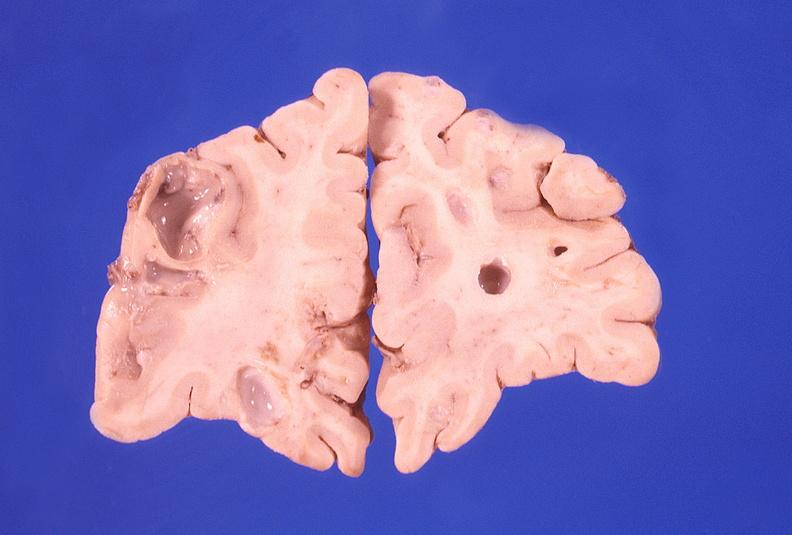s nervous present?
Answer the question using a single word or phrase. Yes 